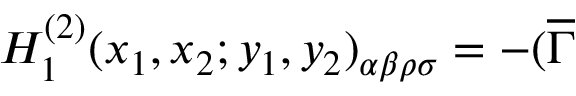Convert formula to latex. <formula><loc_0><loc_0><loc_500><loc_500>H _ { 1 } ^ { ( 2 ) } ( x _ { 1 } , x _ { 2 } ; y _ { 1 } , y _ { 2 } ) _ { \alpha \beta \rho \sigma } = - ( \overline { \Gamma }</formula> 